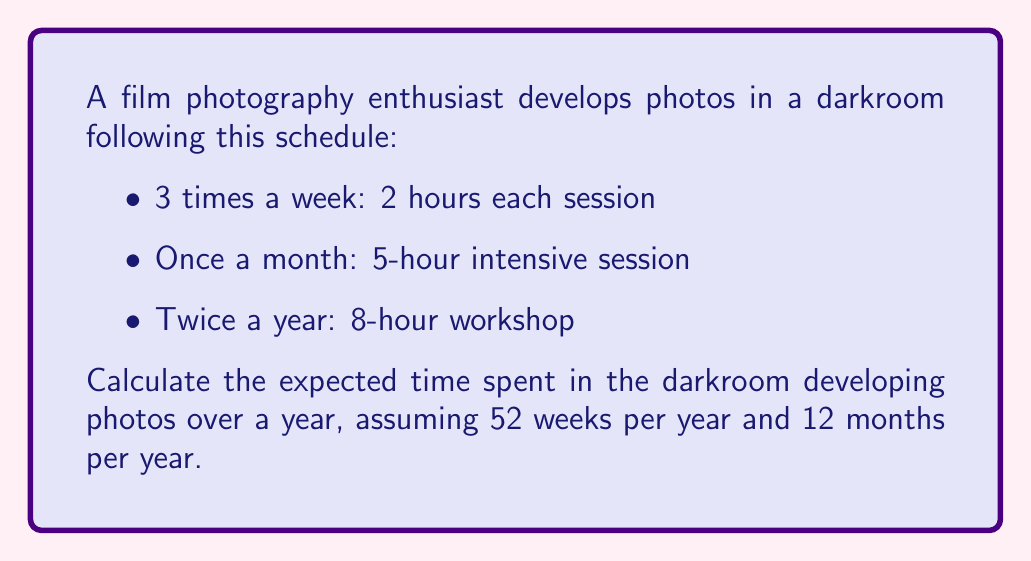Give your solution to this math problem. Let's break this down step-by-step:

1. Weekly sessions:
   - 3 times a week, 2 hours each
   - Time per week: $3 \times 2 = 6$ hours
   - Time per year: $6 \times 52 = 312$ hours

2. Monthly sessions:
   - Once a month, 5 hours each
   - Time per year: $5 \times 12 = 60$ hours

3. Bi-annual workshops:
   - Twice a year, 8 hours each
   - Time per year: $8 \times 2 = 16$ hours

4. Total expected time:
   $$\text{Total time} = \text{Weekly sessions} + \text{Monthly sessions} + \text{Bi-annual workshops}$$
   $$\text{Total time} = 312 + 60 + 16 = 388 \text{ hours}$$

Therefore, the expected time spent in the darkroom developing photos over a year is 388 hours.
Answer: 388 hours 